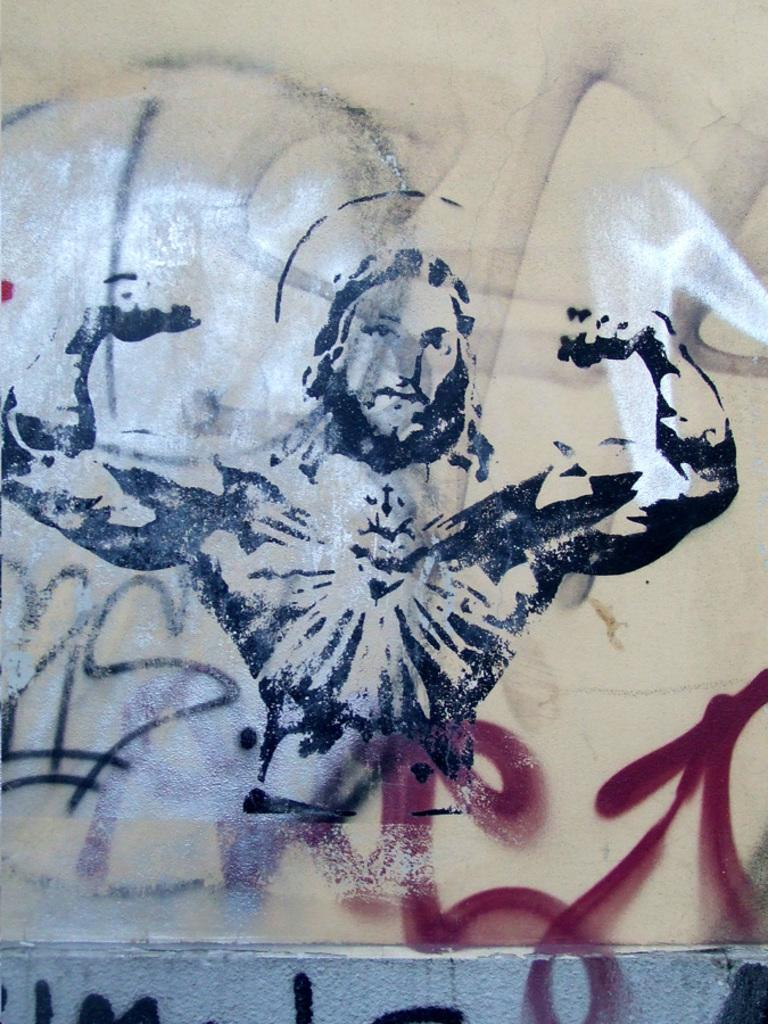What can be seen on the wall in the image? There are paintings on the wall in the image. What type of ring can be seen on the goat's neck in the image? There is no goat or ring present in the image; it only features paintings on the wall. 